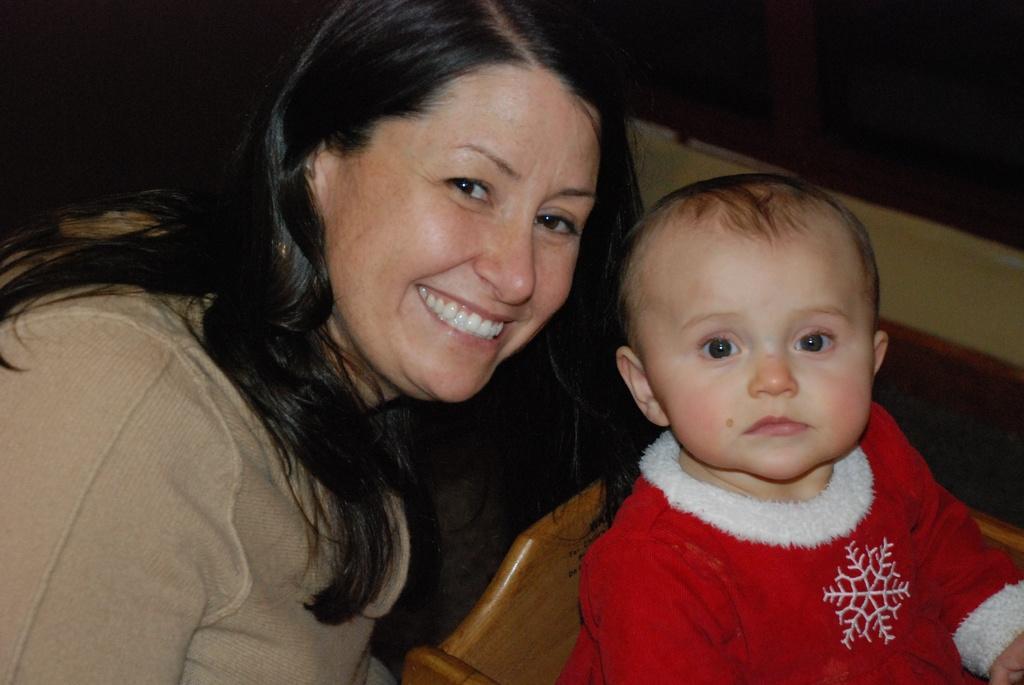Describe this image in one or two sentences. In this picture I can observe a woman and baby. Baby is wearing red color dress. Woman is smiling. The background is completely dark. 